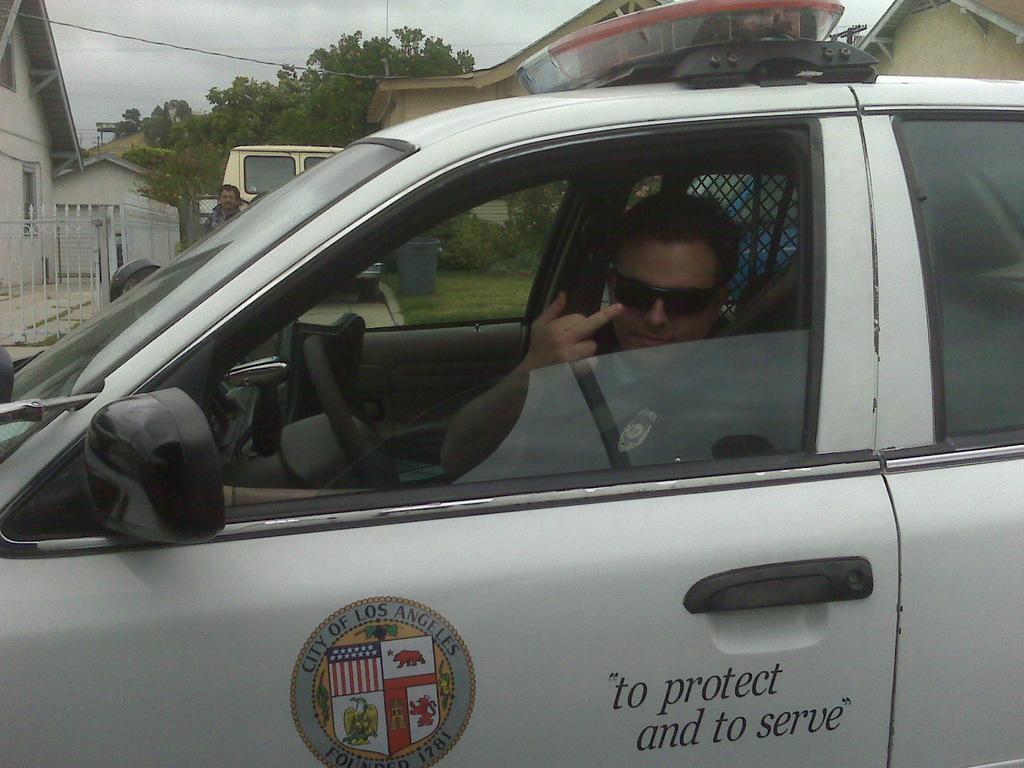Could you give a brief overview of what you see in this image? In the image there is a man sitting on white color car in background there is a another man standing and van buildings on right and left side trees and sky is on top. 